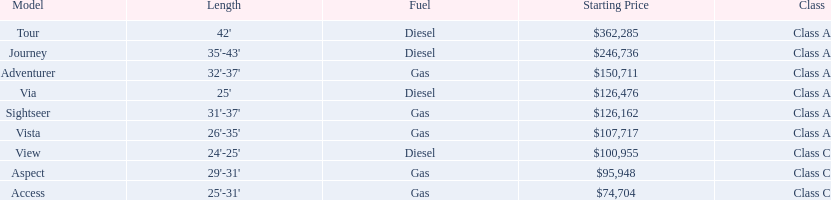How long is the aspect? 29'-31'. 